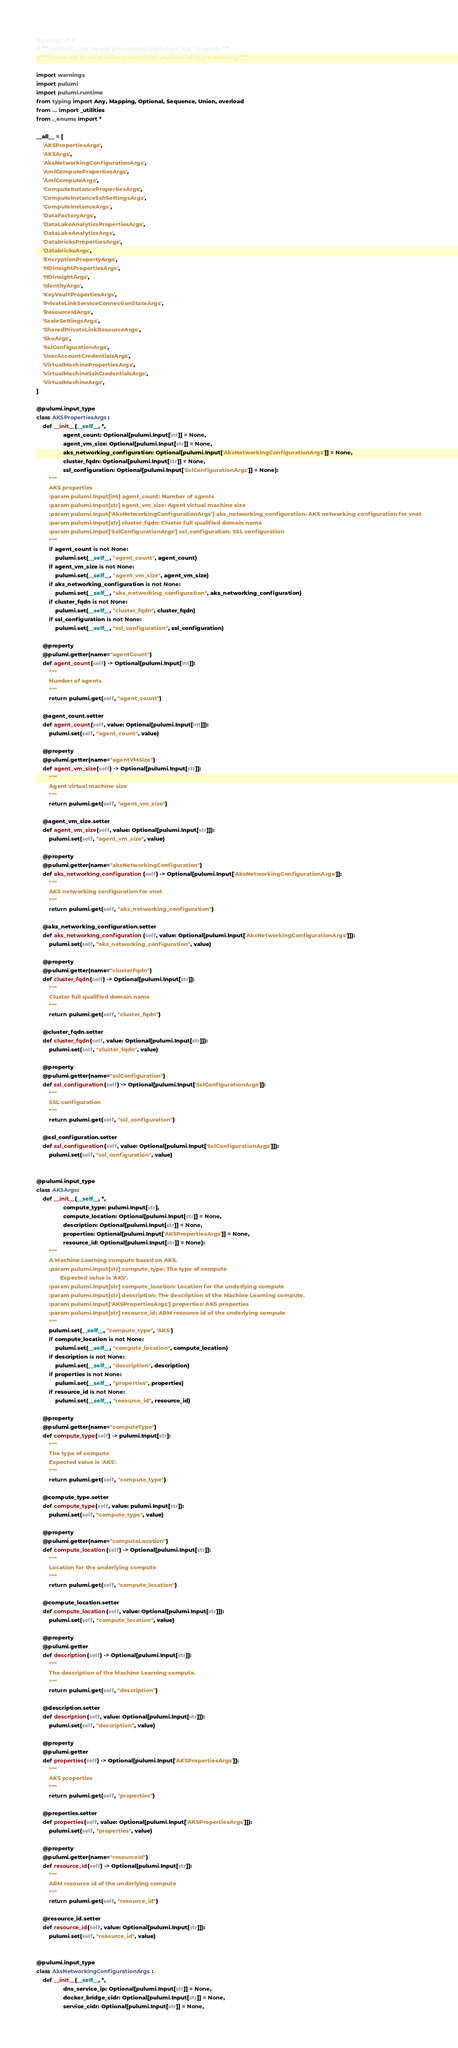<code> <loc_0><loc_0><loc_500><loc_500><_Python_># coding=utf-8
# *** WARNING: this file was generated by the Pulumi SDK Generator. ***
# *** Do not edit by hand unless you're certain you know what you are doing! ***

import warnings
import pulumi
import pulumi.runtime
from typing import Any, Mapping, Optional, Sequence, Union, overload
from ... import _utilities
from ._enums import *

__all__ = [
    'AKSPropertiesArgs',
    'AKSArgs',
    'AksNetworkingConfigurationArgs',
    'AmlComputePropertiesArgs',
    'AmlComputeArgs',
    'ComputeInstancePropertiesArgs',
    'ComputeInstanceSshSettingsArgs',
    'ComputeInstanceArgs',
    'DataFactoryArgs',
    'DataLakeAnalyticsPropertiesArgs',
    'DataLakeAnalyticsArgs',
    'DatabricksPropertiesArgs',
    'DatabricksArgs',
    'EncryptionPropertyArgs',
    'HDInsightPropertiesArgs',
    'HDInsightArgs',
    'IdentityArgs',
    'KeyVaultPropertiesArgs',
    'PrivateLinkServiceConnectionStateArgs',
    'ResourceIdArgs',
    'ScaleSettingsArgs',
    'SharedPrivateLinkResourceArgs',
    'SkuArgs',
    'SslConfigurationArgs',
    'UserAccountCredentialsArgs',
    'VirtualMachinePropertiesArgs',
    'VirtualMachineSshCredentialsArgs',
    'VirtualMachineArgs',
]

@pulumi.input_type
class AKSPropertiesArgs:
    def __init__(__self__, *,
                 agent_count: Optional[pulumi.Input[int]] = None,
                 agent_vm_size: Optional[pulumi.Input[str]] = None,
                 aks_networking_configuration: Optional[pulumi.Input['AksNetworkingConfigurationArgs']] = None,
                 cluster_fqdn: Optional[pulumi.Input[str]] = None,
                 ssl_configuration: Optional[pulumi.Input['SslConfigurationArgs']] = None):
        """
        AKS properties
        :param pulumi.Input[int] agent_count: Number of agents
        :param pulumi.Input[str] agent_vm_size: Agent virtual machine size
        :param pulumi.Input['AksNetworkingConfigurationArgs'] aks_networking_configuration: AKS networking configuration for vnet
        :param pulumi.Input[str] cluster_fqdn: Cluster full qualified domain name
        :param pulumi.Input['SslConfigurationArgs'] ssl_configuration: SSL configuration
        """
        if agent_count is not None:
            pulumi.set(__self__, "agent_count", agent_count)
        if agent_vm_size is not None:
            pulumi.set(__self__, "agent_vm_size", agent_vm_size)
        if aks_networking_configuration is not None:
            pulumi.set(__self__, "aks_networking_configuration", aks_networking_configuration)
        if cluster_fqdn is not None:
            pulumi.set(__self__, "cluster_fqdn", cluster_fqdn)
        if ssl_configuration is not None:
            pulumi.set(__self__, "ssl_configuration", ssl_configuration)

    @property
    @pulumi.getter(name="agentCount")
    def agent_count(self) -> Optional[pulumi.Input[int]]:
        """
        Number of agents
        """
        return pulumi.get(self, "agent_count")

    @agent_count.setter
    def agent_count(self, value: Optional[pulumi.Input[int]]):
        pulumi.set(self, "agent_count", value)

    @property
    @pulumi.getter(name="agentVMSize")
    def agent_vm_size(self) -> Optional[pulumi.Input[str]]:
        """
        Agent virtual machine size
        """
        return pulumi.get(self, "agent_vm_size")

    @agent_vm_size.setter
    def agent_vm_size(self, value: Optional[pulumi.Input[str]]):
        pulumi.set(self, "agent_vm_size", value)

    @property
    @pulumi.getter(name="aksNetworkingConfiguration")
    def aks_networking_configuration(self) -> Optional[pulumi.Input['AksNetworkingConfigurationArgs']]:
        """
        AKS networking configuration for vnet
        """
        return pulumi.get(self, "aks_networking_configuration")

    @aks_networking_configuration.setter
    def aks_networking_configuration(self, value: Optional[pulumi.Input['AksNetworkingConfigurationArgs']]):
        pulumi.set(self, "aks_networking_configuration", value)

    @property
    @pulumi.getter(name="clusterFqdn")
    def cluster_fqdn(self) -> Optional[pulumi.Input[str]]:
        """
        Cluster full qualified domain name
        """
        return pulumi.get(self, "cluster_fqdn")

    @cluster_fqdn.setter
    def cluster_fqdn(self, value: Optional[pulumi.Input[str]]):
        pulumi.set(self, "cluster_fqdn", value)

    @property
    @pulumi.getter(name="sslConfiguration")
    def ssl_configuration(self) -> Optional[pulumi.Input['SslConfigurationArgs']]:
        """
        SSL configuration
        """
        return pulumi.get(self, "ssl_configuration")

    @ssl_configuration.setter
    def ssl_configuration(self, value: Optional[pulumi.Input['SslConfigurationArgs']]):
        pulumi.set(self, "ssl_configuration", value)


@pulumi.input_type
class AKSArgs:
    def __init__(__self__, *,
                 compute_type: pulumi.Input[str],
                 compute_location: Optional[pulumi.Input[str]] = None,
                 description: Optional[pulumi.Input[str]] = None,
                 properties: Optional[pulumi.Input['AKSPropertiesArgs']] = None,
                 resource_id: Optional[pulumi.Input[str]] = None):
        """
        A Machine Learning compute based on AKS.
        :param pulumi.Input[str] compute_type: The type of compute
               Expected value is 'AKS'.
        :param pulumi.Input[str] compute_location: Location for the underlying compute
        :param pulumi.Input[str] description: The description of the Machine Learning compute.
        :param pulumi.Input['AKSPropertiesArgs'] properties: AKS properties
        :param pulumi.Input[str] resource_id: ARM resource id of the underlying compute
        """
        pulumi.set(__self__, "compute_type", 'AKS')
        if compute_location is not None:
            pulumi.set(__self__, "compute_location", compute_location)
        if description is not None:
            pulumi.set(__self__, "description", description)
        if properties is not None:
            pulumi.set(__self__, "properties", properties)
        if resource_id is not None:
            pulumi.set(__self__, "resource_id", resource_id)

    @property
    @pulumi.getter(name="computeType")
    def compute_type(self) -> pulumi.Input[str]:
        """
        The type of compute
        Expected value is 'AKS'.
        """
        return pulumi.get(self, "compute_type")

    @compute_type.setter
    def compute_type(self, value: pulumi.Input[str]):
        pulumi.set(self, "compute_type", value)

    @property
    @pulumi.getter(name="computeLocation")
    def compute_location(self) -> Optional[pulumi.Input[str]]:
        """
        Location for the underlying compute
        """
        return pulumi.get(self, "compute_location")

    @compute_location.setter
    def compute_location(self, value: Optional[pulumi.Input[str]]):
        pulumi.set(self, "compute_location", value)

    @property
    @pulumi.getter
    def description(self) -> Optional[pulumi.Input[str]]:
        """
        The description of the Machine Learning compute.
        """
        return pulumi.get(self, "description")

    @description.setter
    def description(self, value: Optional[pulumi.Input[str]]):
        pulumi.set(self, "description", value)

    @property
    @pulumi.getter
    def properties(self) -> Optional[pulumi.Input['AKSPropertiesArgs']]:
        """
        AKS properties
        """
        return pulumi.get(self, "properties")

    @properties.setter
    def properties(self, value: Optional[pulumi.Input['AKSPropertiesArgs']]):
        pulumi.set(self, "properties", value)

    @property
    @pulumi.getter(name="resourceId")
    def resource_id(self) -> Optional[pulumi.Input[str]]:
        """
        ARM resource id of the underlying compute
        """
        return pulumi.get(self, "resource_id")

    @resource_id.setter
    def resource_id(self, value: Optional[pulumi.Input[str]]):
        pulumi.set(self, "resource_id", value)


@pulumi.input_type
class AksNetworkingConfigurationArgs:
    def __init__(__self__, *,
                 dns_service_ip: Optional[pulumi.Input[str]] = None,
                 docker_bridge_cidr: Optional[pulumi.Input[str]] = None,
                 service_cidr: Optional[pulumi.Input[str]] = None,</code> 